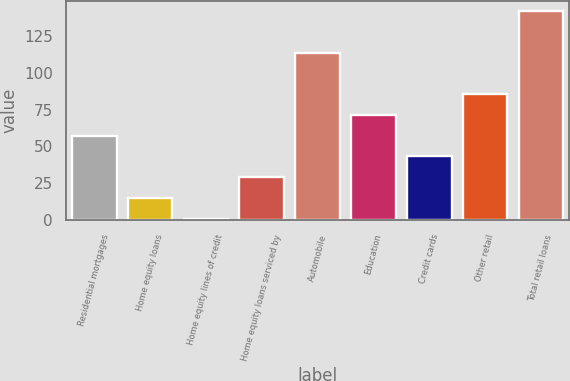<chart> <loc_0><loc_0><loc_500><loc_500><bar_chart><fcel>Residential mortgages<fcel>Home equity loans<fcel>Home equity lines of credit<fcel>Home equity loans serviced by<fcel>Automobile<fcel>Education<fcel>Credit cards<fcel>Other retail<fcel>Total retail loans<nl><fcel>57.4<fcel>15.1<fcel>1<fcel>29.2<fcel>113.8<fcel>71.5<fcel>43.3<fcel>85.6<fcel>142<nl></chart> 